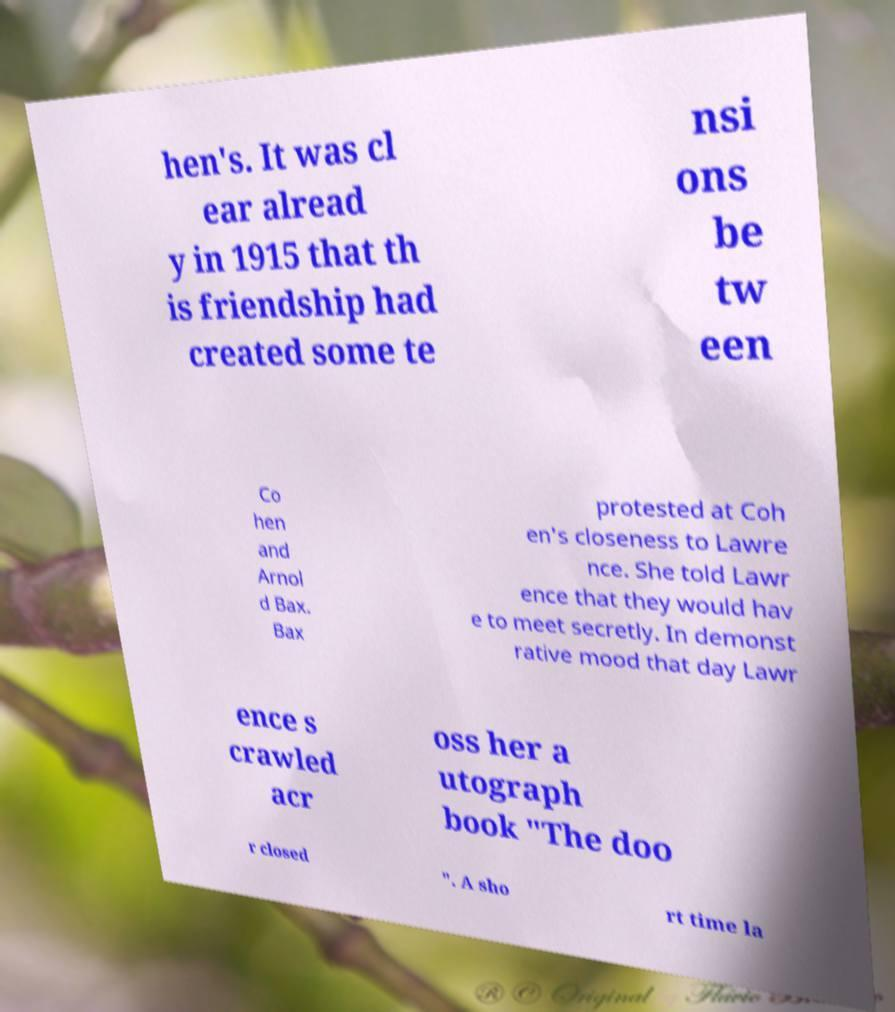Can you accurately transcribe the text from the provided image for me? hen's. It was cl ear alread y in 1915 that th is friendship had created some te nsi ons be tw een Co hen and Arnol d Bax. Bax protested at Coh en's closeness to Lawre nce. She told Lawr ence that they would hav e to meet secretly. In demonst rative mood that day Lawr ence s crawled acr oss her a utograph book "The doo r closed ". A sho rt time la 